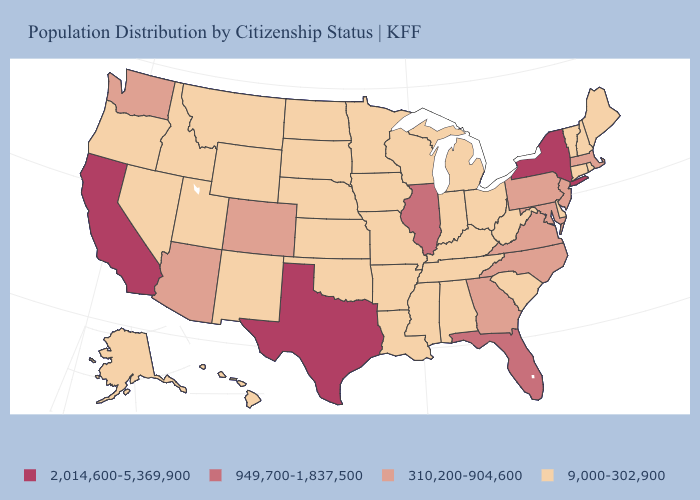How many symbols are there in the legend?
Answer briefly. 4. Which states have the lowest value in the South?
Write a very short answer. Alabama, Arkansas, Delaware, Kentucky, Louisiana, Mississippi, Oklahoma, South Carolina, Tennessee, West Virginia. Does the map have missing data?
Keep it brief. No. What is the value of Minnesota?
Give a very brief answer. 9,000-302,900. How many symbols are there in the legend?
Write a very short answer. 4. Name the states that have a value in the range 310,200-904,600?
Write a very short answer. Arizona, Colorado, Georgia, Maryland, Massachusetts, New Jersey, North Carolina, Pennsylvania, Virginia, Washington. What is the value of Wyoming?
Write a very short answer. 9,000-302,900. What is the highest value in states that border Louisiana?
Short answer required. 2,014,600-5,369,900. What is the lowest value in the USA?
Quick response, please. 9,000-302,900. Among the states that border Indiana , does Illinois have the lowest value?
Be succinct. No. Does the map have missing data?
Write a very short answer. No. What is the value of New Jersey?
Keep it brief. 310,200-904,600. Does Louisiana have a lower value than Minnesota?
Concise answer only. No. Name the states that have a value in the range 310,200-904,600?
Short answer required. Arizona, Colorado, Georgia, Maryland, Massachusetts, New Jersey, North Carolina, Pennsylvania, Virginia, Washington. 